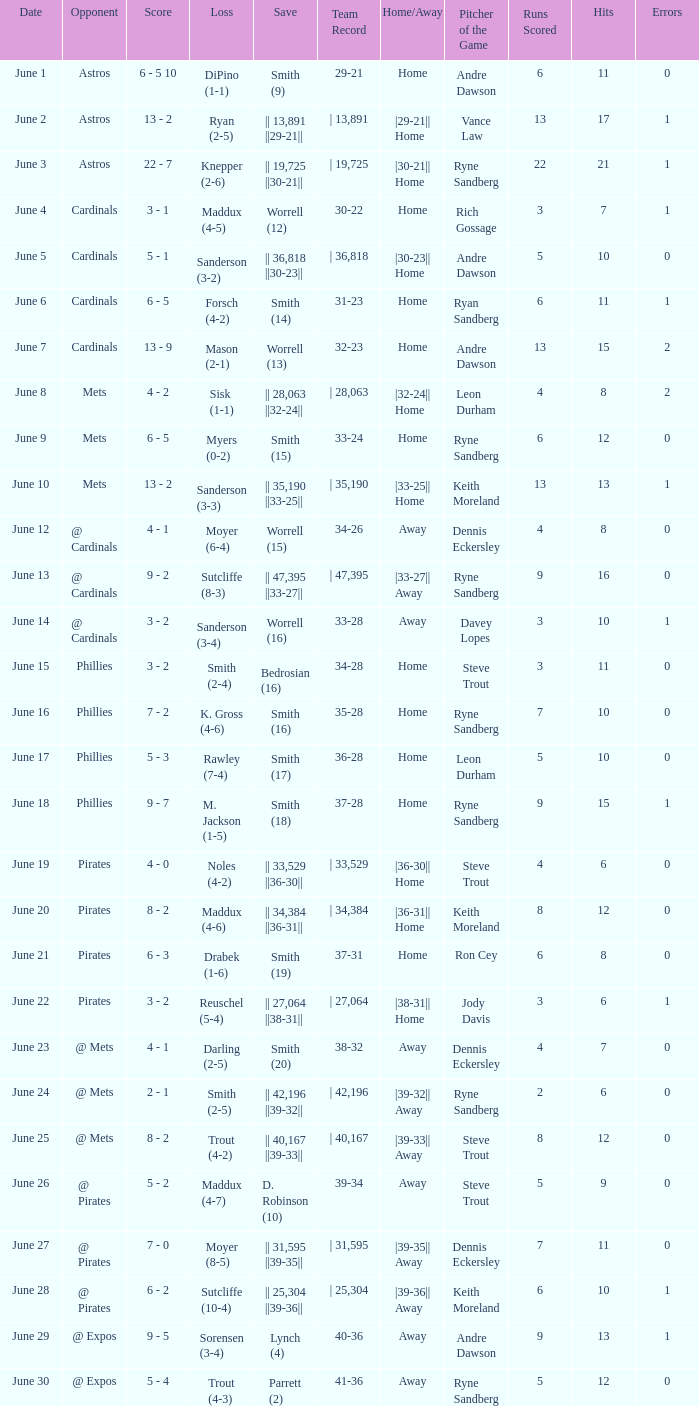When smith's loss was (2-4), what was the end score of the game? 3 - 2. 